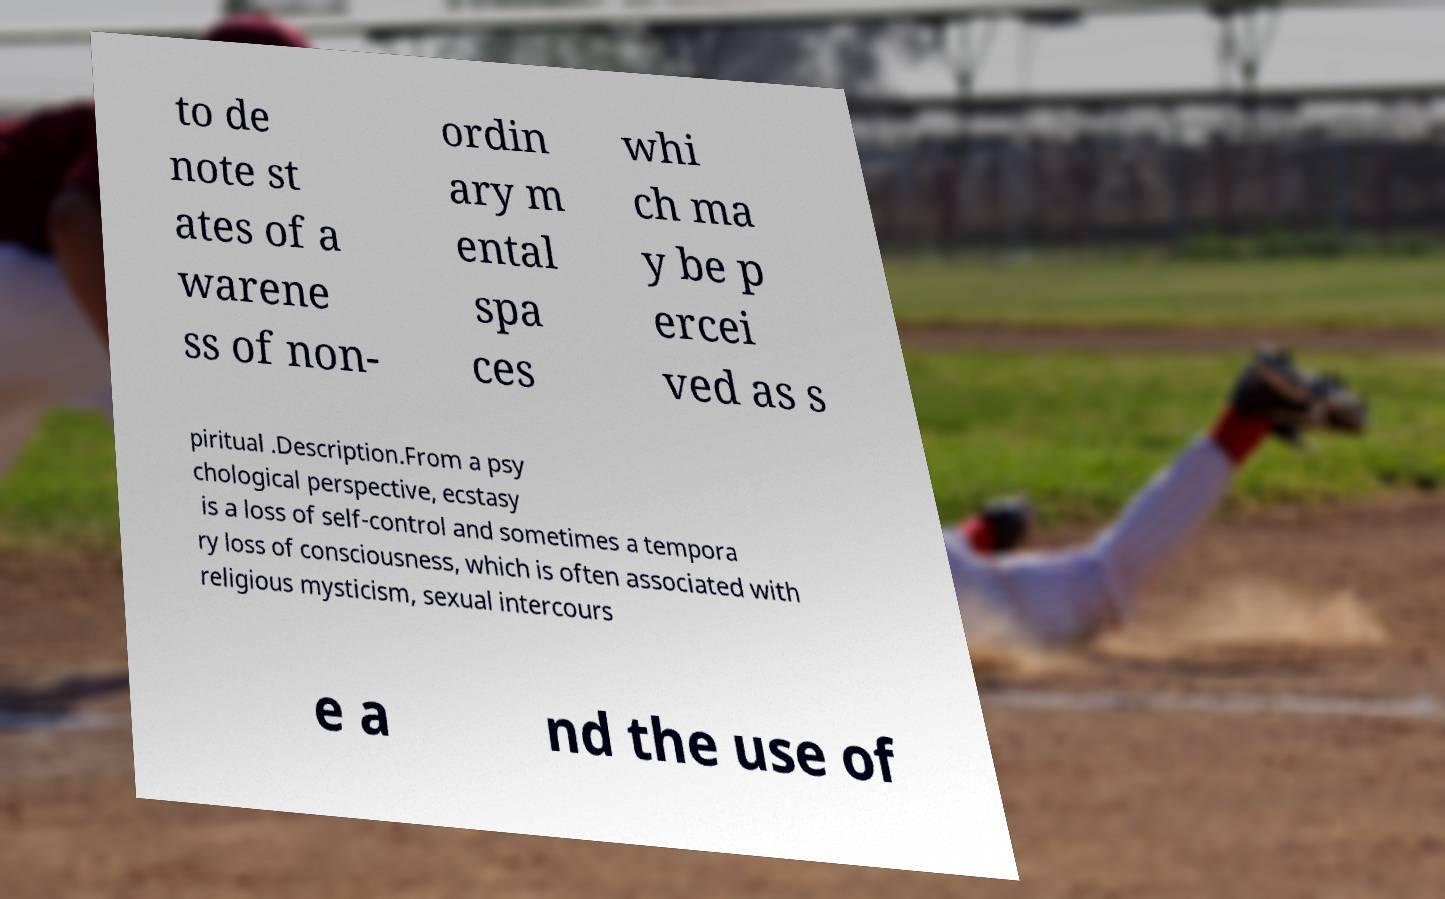Could you extract and type out the text from this image? to de note st ates of a warene ss of non- ordin ary m ental spa ces whi ch ma y be p ercei ved as s piritual .Description.From a psy chological perspective, ecstasy is a loss of self-control and sometimes a tempora ry loss of consciousness, which is often associated with religious mysticism, sexual intercours e a nd the use of 